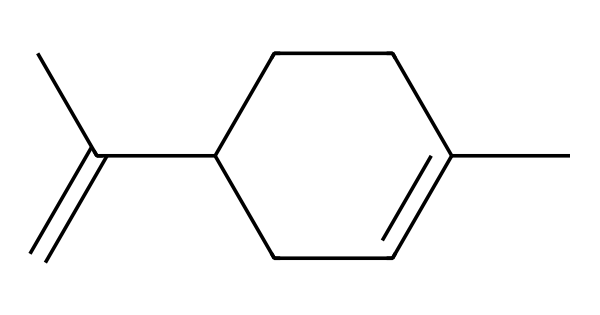What is the total number of carbon atoms in limonene? By analyzing the SMILES representation, each "C" stands for a carbon atom. Count the "C" symbols: there are a total of 10 carbon atoms in the structure.
Answer: 10 What type of bonds are present in limonene? The structure exhibits both single bonds (between carbon atoms) and a double bond (indicated by "=" in the SMILES), which is characteristic of the alkene functional groups.
Answer: single and double bonds Is limonene a cyclic compound? In the SMILES representation, the "CC1" and "CC1" notation indicates the presence of a ring, confirming that limonene is a cyclic compound.
Answer: Yes What functional group is primarily represented in limonene? Limonene contains a double bond which is indicative of the alkene functional group, as shown by the "C=C" in the structure.
Answer: alkene How many hydrogen atoms are in limonene? To determine the number of hydrogen atoms, we can use the formula CnH(2n) for alkenes and consider the cyclic nature. For 10 carbon atoms, substituting n = 10 gives H20, but the presence of a double bond reduces the total by 2, yielding H18.
Answer: 18 What type of chemical is limonene classified as? As limonene is a terpene derived from plants, which are known to be volatile and non-electrolytic substances, it falls under the category of non-electrolytes.
Answer: Non-electrolyte 